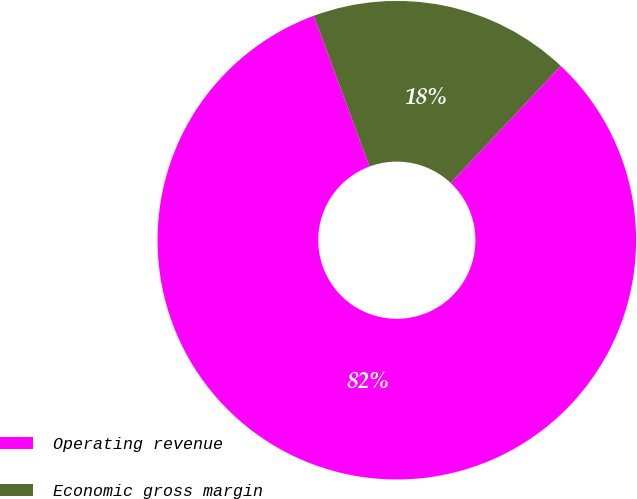Convert chart to OTSL. <chart><loc_0><loc_0><loc_500><loc_500><pie_chart><fcel>Operating revenue<fcel>Economic gross margin<nl><fcel>82.35%<fcel>17.65%<nl></chart> 